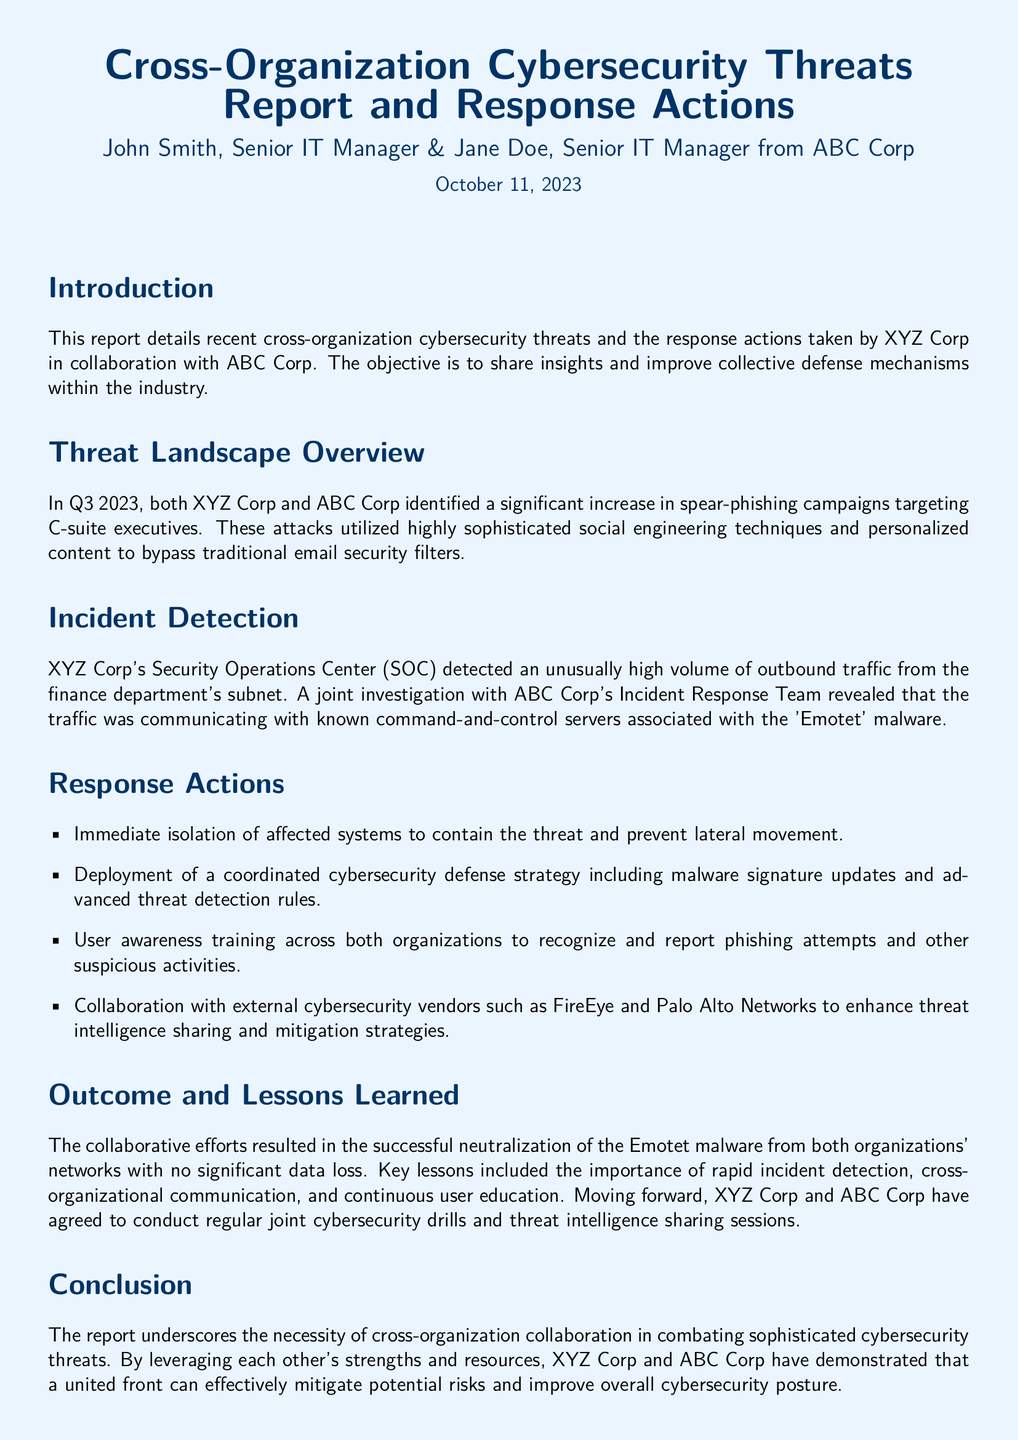What is the date of the report? The date of the report is specified at the beginning, which is October 11, 2023.
Answer: October 11, 2023 Who are the authors of the report? The authors' names are mentioned in the title section of the document, which are John Smith and Jane Doe from ABC Corp.
Answer: John Smith, Jane Doe What type of cyber attacks increased in Q3 2023? The report outlines a specific type of attack that increased, namely spear-phishing campaigns targeting C-suite executives.
Answer: Spear-phishing What was detected by XYZ Corp's Security Operations Center? The SOC detected an unusually high volume of outbound traffic from a specific department, which is the finance department.
Answer: Finance department What malware was associated with the command-and-control servers? The incident revealed that the traffic was communicating with known command-and-control servers linked to a particular malware, which is Emotet.
Answer: Emotet What was one of the response actions taken? The document lists several actions taken, one of which was the immediate isolation of affected systems.
Answer: Isolation of affected systems What lesson was emphasized in the report? One key lesson learned from the incident involved the importance of rapid incident detection across organizations.
Answer: Rapid incident detection How many companies collaborated on this report? The report describes the collaboration between two organizations, namely XYZ Corp and ABC Corp.
Answer: Two organizations 